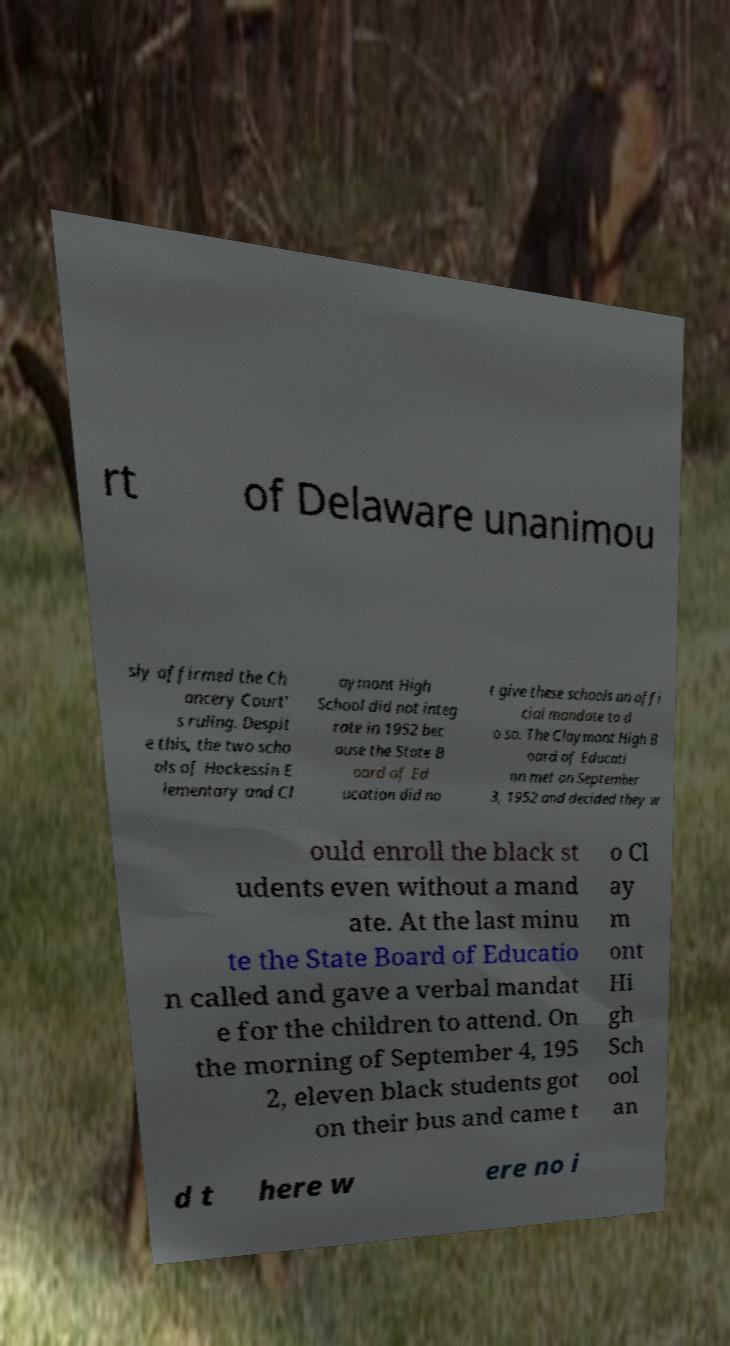Please identify and transcribe the text found in this image. rt of Delaware unanimou sly affirmed the Ch ancery Court' s ruling. Despit e this, the two scho ols of Hockessin E lementary and Cl aymont High School did not integ rate in 1952 bec ause the State B oard of Ed ucation did no t give these schools an offi cial mandate to d o so. The Claymont High B oard of Educati on met on September 3, 1952 and decided they w ould enroll the black st udents even without a mand ate. At the last minu te the State Board of Educatio n called and gave a verbal mandat e for the children to attend. On the morning of September 4, 195 2, eleven black students got on their bus and came t o Cl ay m ont Hi gh Sch ool an d t here w ere no i 